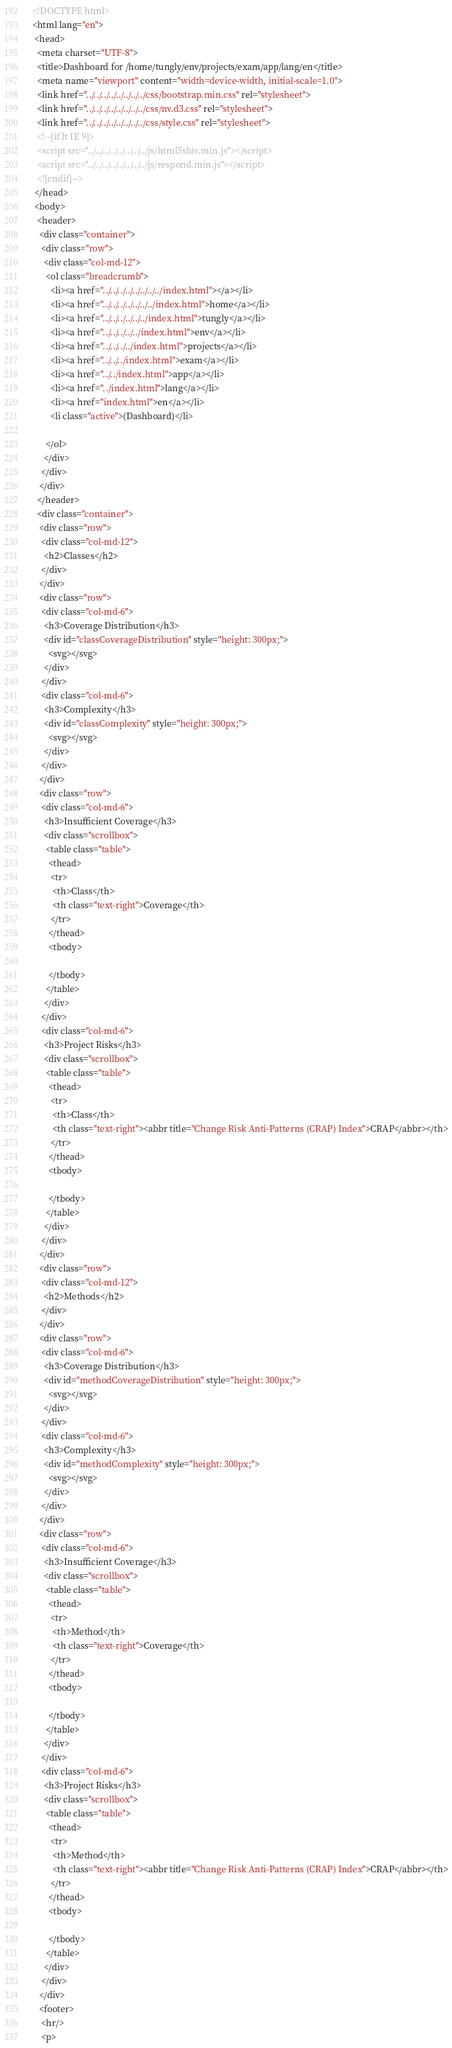Convert code to text. <code><loc_0><loc_0><loc_500><loc_500><_HTML_><!DOCTYPE html>
<html lang="en">
 <head>
  <meta charset="UTF-8">
  <title>Dashboard for /home/tungly/env/projects/exam/app/lang/en</title>
  <meta name="viewport" content="width=device-width, initial-scale=1.0">
  <link href="../../../../../../../../css/bootstrap.min.css" rel="stylesheet">
  <link href="../../../../../../../../css/nv.d3.css" rel="stylesheet">
  <link href="../../../../../../../../css/style.css" rel="stylesheet">
  <!--[if lt IE 9]>
  <script src="../../../../../../../../js/html5shiv.min.js"></script>
  <script src="../../../../../../../../js/respond.min.js"></script>
  <![endif]-->
 </head>
 <body>
  <header>
   <div class="container">
    <div class="row">
     <div class="col-md-12">
      <ol class="breadcrumb">
        <li><a href="../../../../../../../../index.html"></a></li>
        <li><a href="../../../../../../../index.html">home</a></li>
        <li><a href="../../../../../../index.html">tungly</a></li>
        <li><a href="../../../../../index.html">env</a></li>
        <li><a href="../../../../index.html">projects</a></li>
        <li><a href="../../../index.html">exam</a></li>
        <li><a href="../../index.html">app</a></li>
        <li><a href="../index.html">lang</a></li>
        <li><a href="index.html">en</a></li>
        <li class="active">(Dashboard)</li>

      </ol>
     </div>
    </div>
   </div>
  </header>
  <div class="container">
   <div class="row">
    <div class="col-md-12">
     <h2>Classes</h2>
    </div>
   </div>
   <div class="row">
    <div class="col-md-6">
     <h3>Coverage Distribution</h3>
     <div id="classCoverageDistribution" style="height: 300px;">
       <svg></svg>
     </div>
    </div>
    <div class="col-md-6">
     <h3>Complexity</h3>
     <div id="classComplexity" style="height: 300px;">
       <svg></svg>
     </div>
    </div>
   </div>
   <div class="row">
    <div class="col-md-6">
     <h3>Insufficient Coverage</h3>
     <div class="scrollbox">
      <table class="table">
       <thead>
        <tr>
         <th>Class</th>
         <th class="text-right">Coverage</th>
        </tr>
       </thead>
       <tbody>

       </tbody>
      </table>
     </div>
    </div>
    <div class="col-md-6">
     <h3>Project Risks</h3>
     <div class="scrollbox">
      <table class="table">
       <thead>
        <tr>
         <th>Class</th>
         <th class="text-right"><abbr title="Change Risk Anti-Patterns (CRAP) Index">CRAP</abbr></th>
        </tr>
       </thead>
       <tbody>

       </tbody>
      </table>
     </div>
    </div>
   </div>
   <div class="row">
    <div class="col-md-12">
     <h2>Methods</h2>
    </div>
   </div>
   <div class="row">
    <div class="col-md-6">
     <h3>Coverage Distribution</h3>
     <div id="methodCoverageDistribution" style="height: 300px;">
       <svg></svg>
     </div>
    </div>
    <div class="col-md-6">
     <h3>Complexity</h3>
     <div id="methodComplexity" style="height: 300px;">
       <svg></svg>
     </div>
    </div>
   </div>
   <div class="row">
    <div class="col-md-6">
     <h3>Insufficient Coverage</h3>
     <div class="scrollbox">
      <table class="table">
       <thead>
        <tr>
         <th>Method</th>
         <th class="text-right">Coverage</th>
        </tr>
       </thead>
       <tbody>

       </tbody>
      </table>
     </div>
    </div>
    <div class="col-md-6">
     <h3>Project Risks</h3>
     <div class="scrollbox">
      <table class="table">
       <thead>
        <tr>
         <th>Method</th>
         <th class="text-right"><abbr title="Change Risk Anti-Patterns (CRAP) Index">CRAP</abbr></th>
        </tr>
       </thead>
       <tbody>

       </tbody>
      </table>
     </div>
    </div>
   </div>
   <footer>
    <hr/>
    <p></code> 